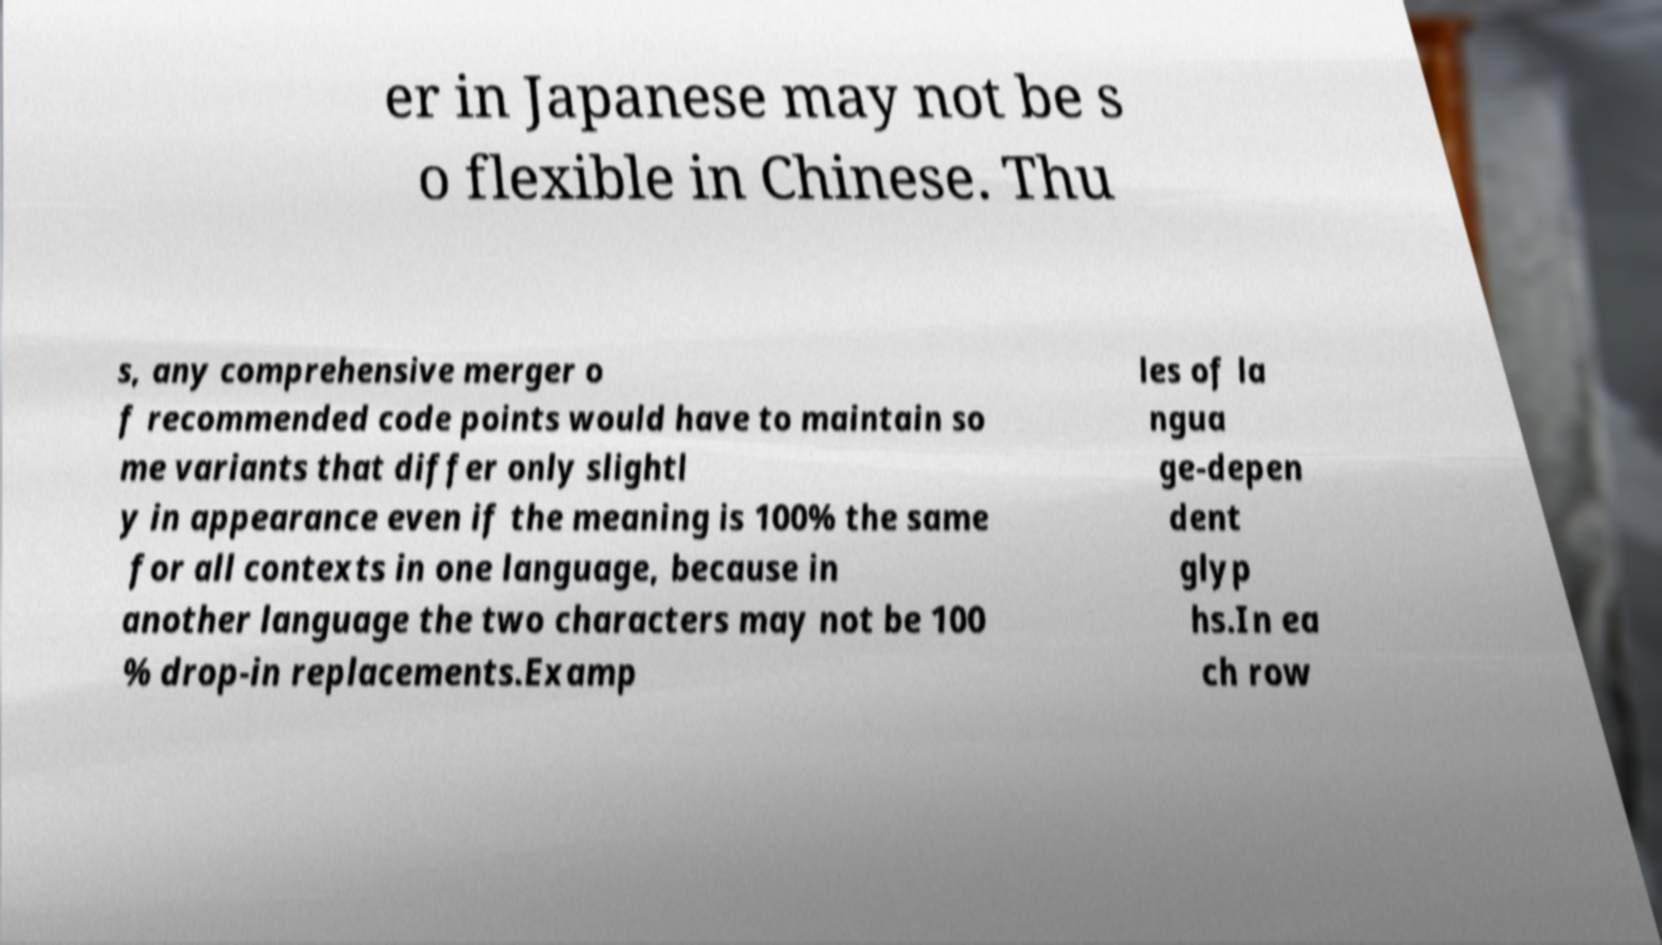For documentation purposes, I need the text within this image transcribed. Could you provide that? er in Japanese may not be s o flexible in Chinese. Thu s, any comprehensive merger o f recommended code points would have to maintain so me variants that differ only slightl y in appearance even if the meaning is 100% the same for all contexts in one language, because in another language the two characters may not be 100 % drop-in replacements.Examp les of la ngua ge-depen dent glyp hs.In ea ch row 